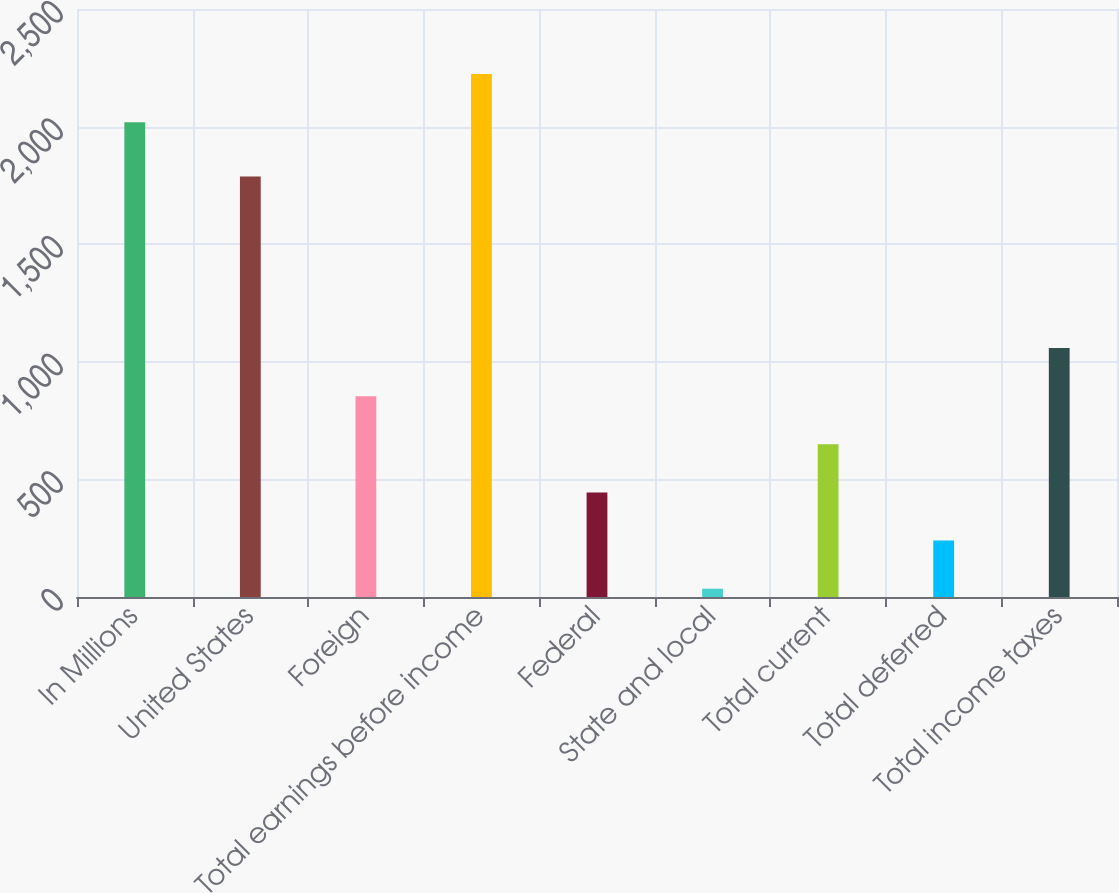Convert chart. <chart><loc_0><loc_0><loc_500><loc_500><bar_chart><fcel>In Millions<fcel>United States<fcel>Foreign<fcel>Total earnings before income<fcel>Federal<fcel>State and local<fcel>Total current<fcel>Total deferred<fcel>Total income taxes<nl><fcel>2019<fcel>1788.2<fcel>853.98<fcel>2223.67<fcel>444.64<fcel>35.3<fcel>649.31<fcel>239.97<fcel>1058.65<nl></chart> 